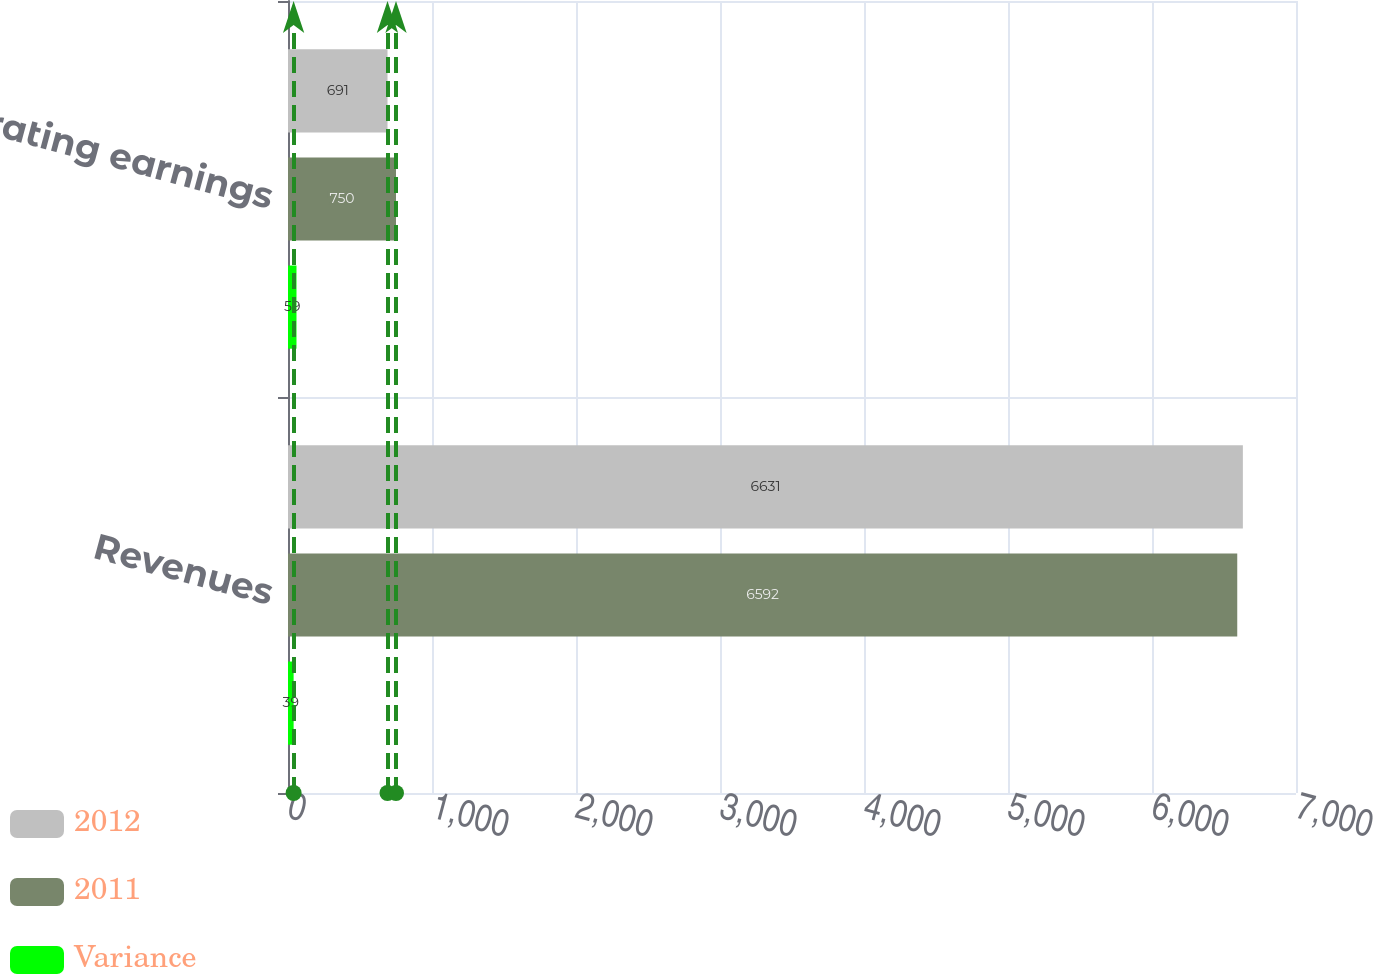<chart> <loc_0><loc_0><loc_500><loc_500><stacked_bar_chart><ecel><fcel>Revenues<fcel>Operating earnings<nl><fcel>2012<fcel>6631<fcel>691<nl><fcel>2011<fcel>6592<fcel>750<nl><fcel>Variance<fcel>39<fcel>59<nl></chart> 